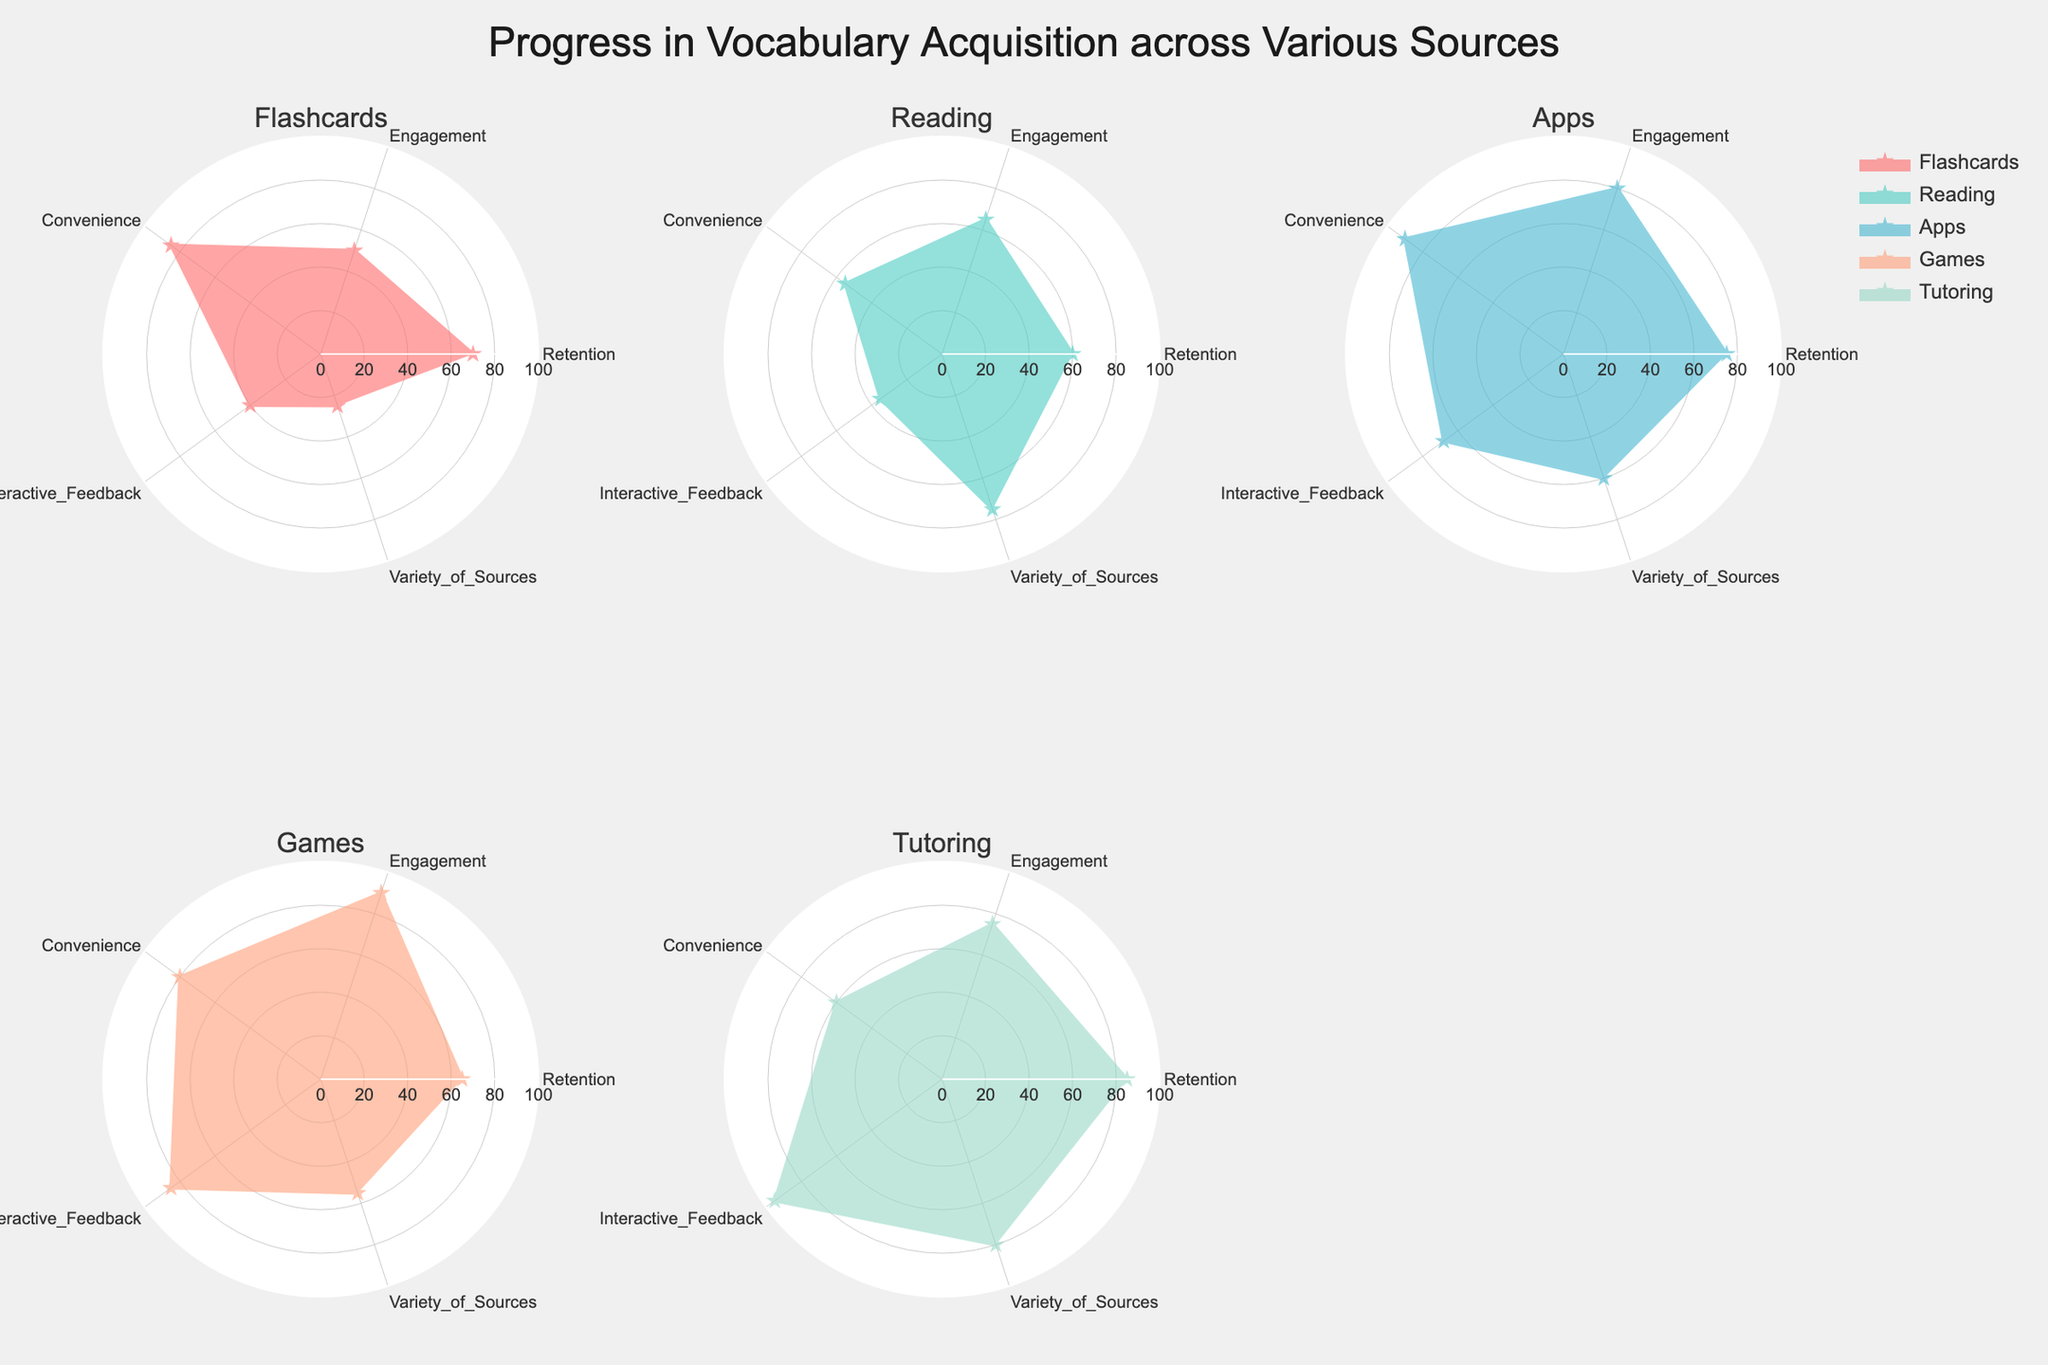What are the categories displayed on the radar charts? The categories are the axes on each radar chart representing different aspects of vocabulary acquisition. Looking at the figure, the categories are Retention, Engagement, Convenience, Interactive Feedback, and Variety of Sources.
Answer: Retention, Engagement, Convenience, Interactive Feedback, Variety of Sources Which source shows the highest engagement score? Engagement is one of the categories, and each data point represents a source on the radar chart. The source with the highest value in the Engagement category is Games with a score of 90.
Answer: Games What source has the lowest value in the Interactive Feedback category? Interactive Feedback is one of the categories. By looking at the charts in that category, Flashcards have the lowest value with a score of 40.
Answer: Flashcards What is the average retention score across all sources? The retention scores for all sources are 70, 60, 75, 65, and 85. The average is calculated as (70 + 60 + 75 + 65 + 85)/5 = 71.
Answer: 71 Which categories have the highest scores in Tutoring? In the Tutoring radar chart, check each category's value. The categories with the highest scores are Interactive Feedback (95) and Retention (85).
Answer: Interactive Feedback, Retention Compare the engagement scores of Apps and Tutoring. Which is higher and by how much? Engagement scores are 80 for Apps and 75 for Tutoring. The difference, calculated as 80 - 75, shows that Apps have a higher engagement score by 5.
Answer: Apps by 5 Which source shows the highest convenience score? Convenience is one of the categories. In the corresponding place on the radar charts, Apps have the highest score with 90.
Answer: Apps What is the combined score for all categories in Reading? The scores for Reading are Retention (60), Engagement (65), Convenience (55), Interactive Feedback (35), and Variety of Sources (75). The combined score is 60 + 65 + 55 + 35 + 75 = 290.
Answer: 290 Which source has the most balanced scores across all categories? The most balanced source would have similar values across all categories. By inspecting each chart, it appears that Tutoring shows relatively consistent values across categories compared to other sources.
Answer: Tutoring 